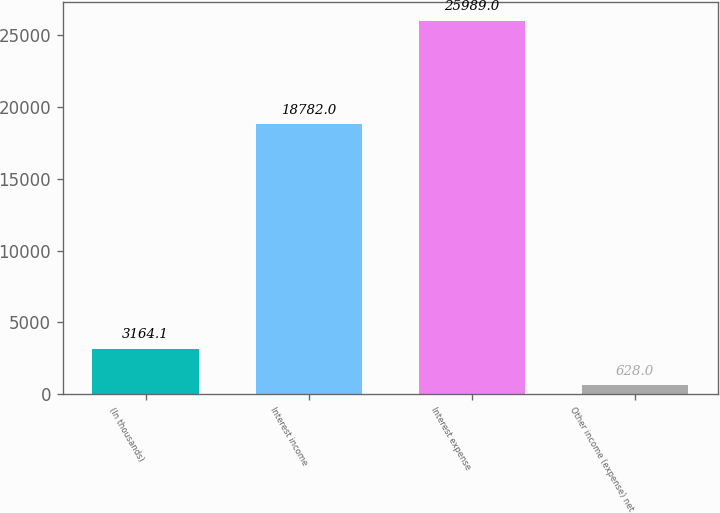Convert chart to OTSL. <chart><loc_0><loc_0><loc_500><loc_500><bar_chart><fcel>(In thousands)<fcel>Interest income<fcel>Interest expense<fcel>Other income (expense) net<nl><fcel>3164.1<fcel>18782<fcel>25989<fcel>628<nl></chart> 